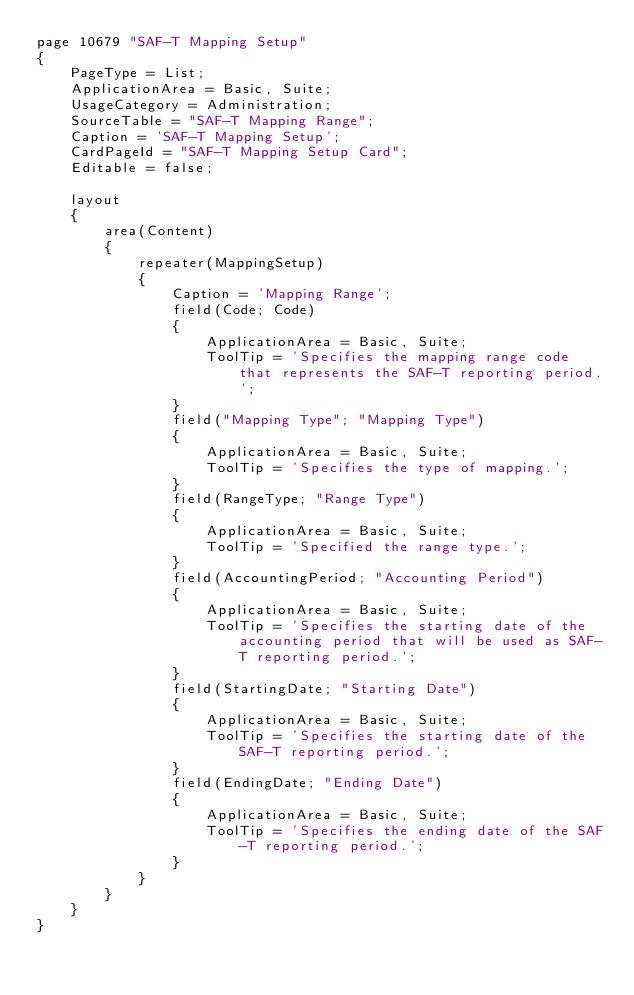Convert code to text. <code><loc_0><loc_0><loc_500><loc_500><_Perl_>page 10679 "SAF-T Mapping Setup"
{
    PageType = List;
    ApplicationArea = Basic, Suite;
    UsageCategory = Administration;
    SourceTable = "SAF-T Mapping Range";
    Caption = 'SAF-T Mapping Setup';
    CardPageId = "SAF-T Mapping Setup Card";
    Editable = false;

    layout
    {
        area(Content)
        {
            repeater(MappingSetup)
            {
                Caption = 'Mapping Range';
                field(Code; Code)
                {
                    ApplicationArea = Basic, Suite;
                    ToolTip = 'Specifies the mapping range code that represents the SAF-T reporting period.';
                }
                field("Mapping Type"; "Mapping Type")
                {
                    ApplicationArea = Basic, Suite;
                    ToolTip = 'Specifies the type of mapping.';
                }
                field(RangeType; "Range Type")
                {
                    ApplicationArea = Basic, Suite;
                    ToolTip = 'Specified the range type.';
                }
                field(AccountingPeriod; "Accounting Period")
                {
                    ApplicationArea = Basic, Suite;
                    ToolTip = 'Specifies the starting date of the accounting period that will be used as SAF-T reporting period.';
                }
                field(StartingDate; "Starting Date")
                {
                    ApplicationArea = Basic, Suite;
                    ToolTip = 'Specifies the starting date of the SAF-T reporting period.';
                }
                field(EndingDate; "Ending Date")
                {
                    ApplicationArea = Basic, Suite;
                    ToolTip = 'Specifies the ending date of the SAF-T reporting period.';
                }
            }
        }
    }
}</code> 